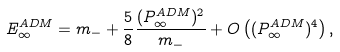<formula> <loc_0><loc_0><loc_500><loc_500>E ^ { A D M } _ { \infty } = m _ { - } + \frac { 5 } { 8 } \frac { ( P ^ { A D M } _ { \infty } ) ^ { 2 } } { m _ { - } } + O \left ( ( P ^ { A D M } _ { \infty } ) ^ { 4 } \right ) ,</formula> 